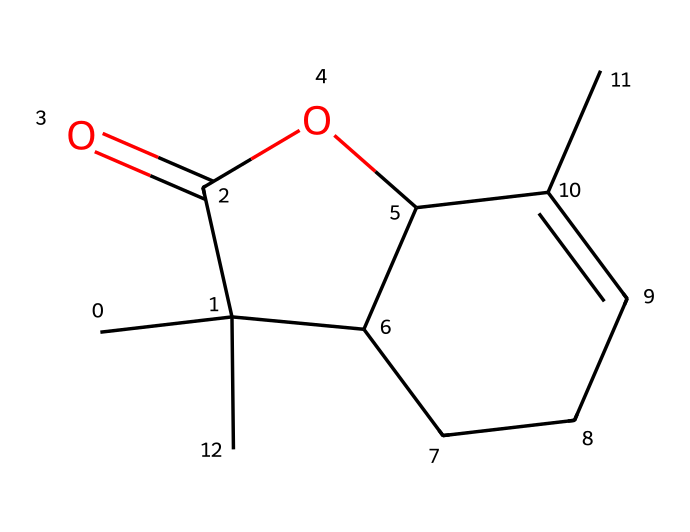What is the molecular formula of nepetalactone? To determine the molecular formula, we count the different types of atoms in the chemical structure represented by the SMILES. This molecule contains 11 carbon (C) atoms, 14 hydrogen (H) atoms, and 2 oxygen (O) atoms, leading to the formula C11H14O2.
Answer: C11H14O2 How many rings are present in the structure of nepetalactone? By analyzing the chemical structure, we can identify the cyclic components. The structure contains two identified rings, one in the cyclohexane-like portion and another in the lactone region. Thus, the total number of rings is two.
Answer: 2 What type of functional group is present in nepetalactone? Nepetalactone contains a lactone functional group, which is characterized by a cyclic ester formed from a carboxylic acid and an alcohol. This is indicated by the presence of the carbonyl (C=O) and ether-like linkage (C-O-C) in the structure.
Answer: lactone Is nepetalactone a saturated or unsaturated compound? In examining the chemical structure, we see the presence of a carbon-carbon double bond in the cyclohexene segment of the molecule. Since this double bond indicates that not all carbon atoms are saturated with hydrogen, nepetalactone is classified as an unsaturated compound.
Answer: unsaturated What is the total number of hydrogen atoms in nepetalactone? By counting the hydrogen atoms in the structure based on the valency of carbon and the bonds shown, we find that there are 14 hydrogen atoms in total bonded to the carbon skeleton in nepetalactone.
Answer: 14 Which part of nepetalactone contributes to its aromatic properties? The structure contains a cyclohexene ring, which has alternating single and double bonds across the carbons that constitute the ring system. This feature imparts a degree of aromatic character to the compound, even though it is not fully aromatic like benzene.
Answer: cyclohexene ring 